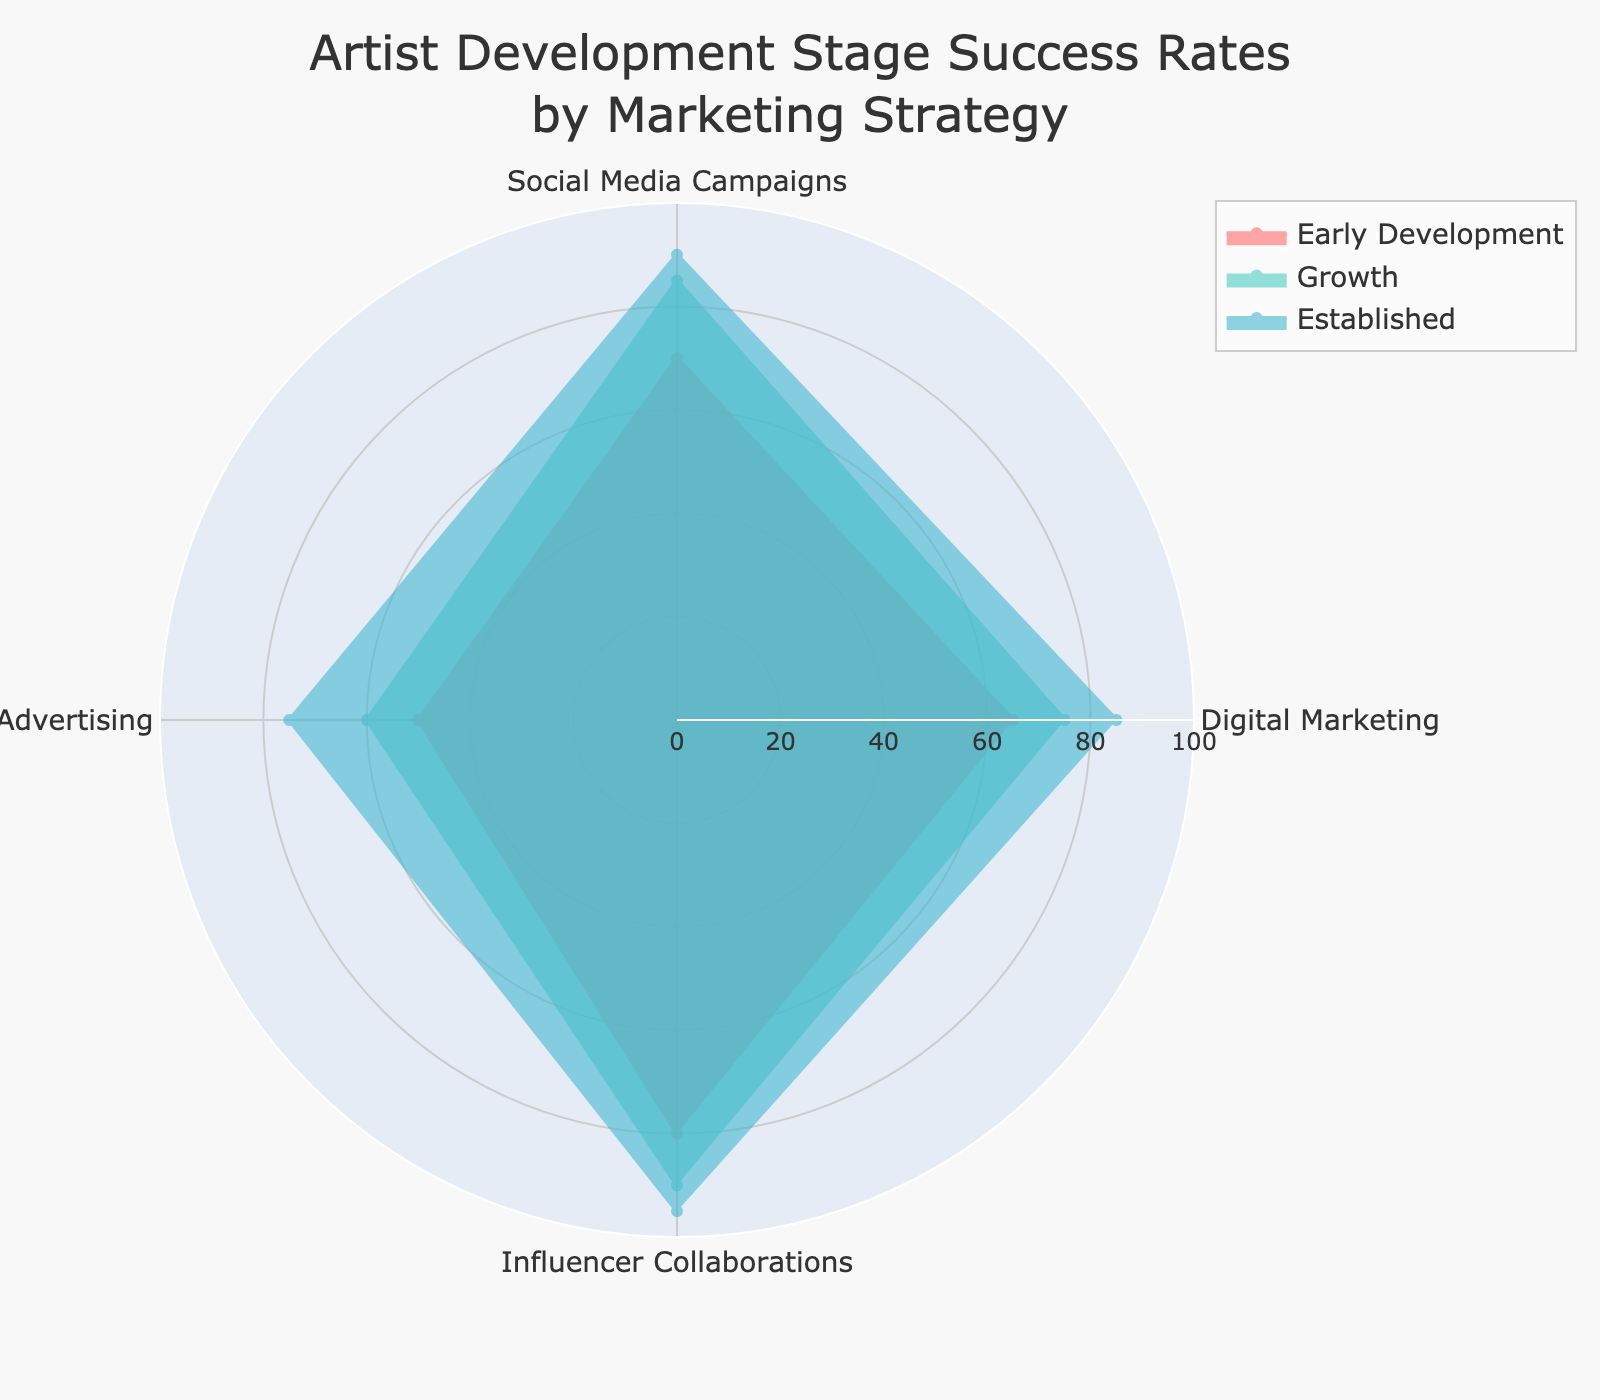What is the maximum success rate for Early Development across all marketing strategies? The maximum success rate for Early Development is observed by looking at all the percentage values given for this stage and identifying the highest. It is 80% in Influencer Collaborations.
Answer: 80% Which marketing strategy has the lowest success rate for Established artists? By examining the percentage values for Established artists across all the strategies, the lowest is for Traditional Advertising at 75%.
Answer: Traditional Advertising Compare the success rates for Digital Marketing and Social Media Campaigns in the Growth stage. Which one is higher and by how much? For the Growth stage, the success rate for Digital Marketing is 75%, while for Social Media Campaigns, it is 85%. The difference is 85% - 75% = 10%.
Answer: Social Media Campaigns by 10% What is the average success rate for Traditional Advertising across all development stages? Sum the success rates for Traditional Advertising across all stages and divide by the number of stages. (50 + 60 + 75) / 3 = 61.67%
Answer: 61.67% Which artist development stage has the most uniform success rates across different marketing strategies? The asnwers is reached by observing the variation in the values for each stage. Early Development: (65, 70, 50, 80), Growth: (75, 85, 60, 90), Established: (85, 90, 75, 95). Growth and Established have larger differences compared to Early Development where the values are closer. Hence, Early Development has the most uniform success rates.
Answer: Early Development For Influencer Collaborations, which stage has the smallest increase in success rate compared to the previous stage? The success rates for Influencer Collaborations are: Early Development (80%), Growth (90%), Established (95%). The increases are 90% - 80% = 10% and 95% - 90% = 5%. The smallest is between Growth and Established stages.
Answer: From Growth to Established Identify one marketing strategy where the success rates increase consistently across all artist development stages. By examining each marketing strategy: Digital Marketing (65, 75, 85), Social Media Campaigns (70, 85, 90), Traditional Advertising (50, 60, 75), Influencer Collaborations (80, 90, 95). All show consistent increases.
Answer: Digital Marketing, Social Media Campaigns, Traditional Advertising, Influencer Collaborations For Social Media Campaigns, calculate the average success rate for the Early Development and Growth stages. Add the success rates for Early Development and Growth stages, then divide by 2. (70 + 85) / 2 = 77.5%
Answer: 77.5% Which stage shows the highest success rate across all marketing strategies? Observing the highest values for each stage and strategy: Early Development (80%), Growth (90%), Established (95%). Established has the highest overall at 95% in Influencer Collaborations.
Answer: Established 